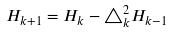Convert formula to latex. <formula><loc_0><loc_0><loc_500><loc_500>H _ { k + 1 } = H _ { k } - \triangle _ { k } ^ { 2 } H _ { k - 1 }</formula> 